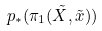Convert formula to latex. <formula><loc_0><loc_0><loc_500><loc_500>p _ { * } ( \pi _ { 1 } ( \tilde { X } , \tilde { x } ) )</formula> 